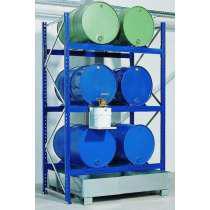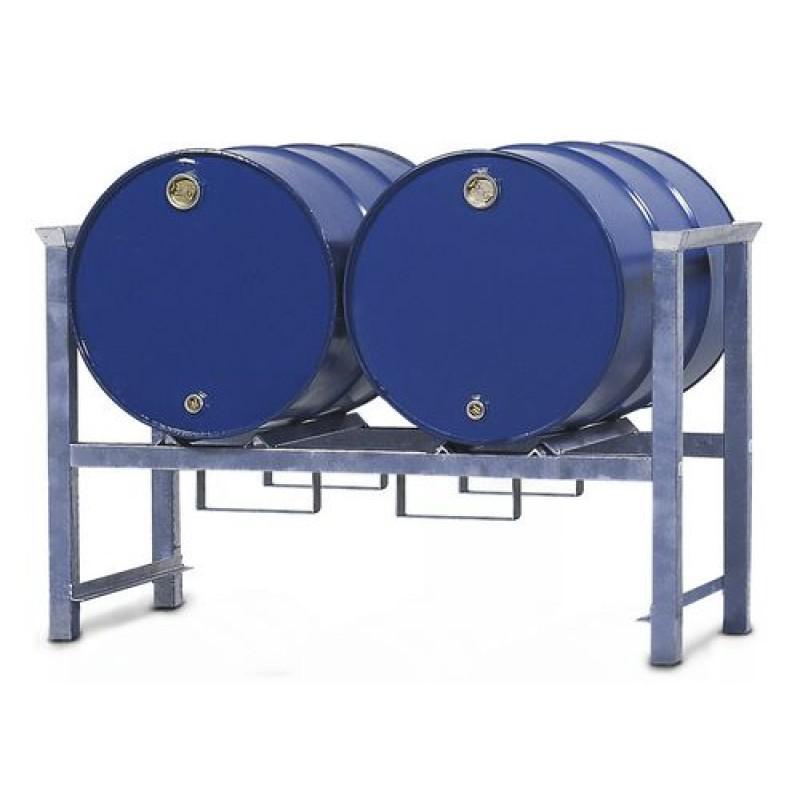The first image is the image on the left, the second image is the image on the right. Examine the images to the left and right. Is the description "One image shows exactly two blue barrels." accurate? Answer yes or no. Yes. The first image is the image on the left, the second image is the image on the right. For the images shown, is this caption "Each image contains at least one blue barrel, and at least 6 blue barrels in total are shown." true? Answer yes or no. Yes. 